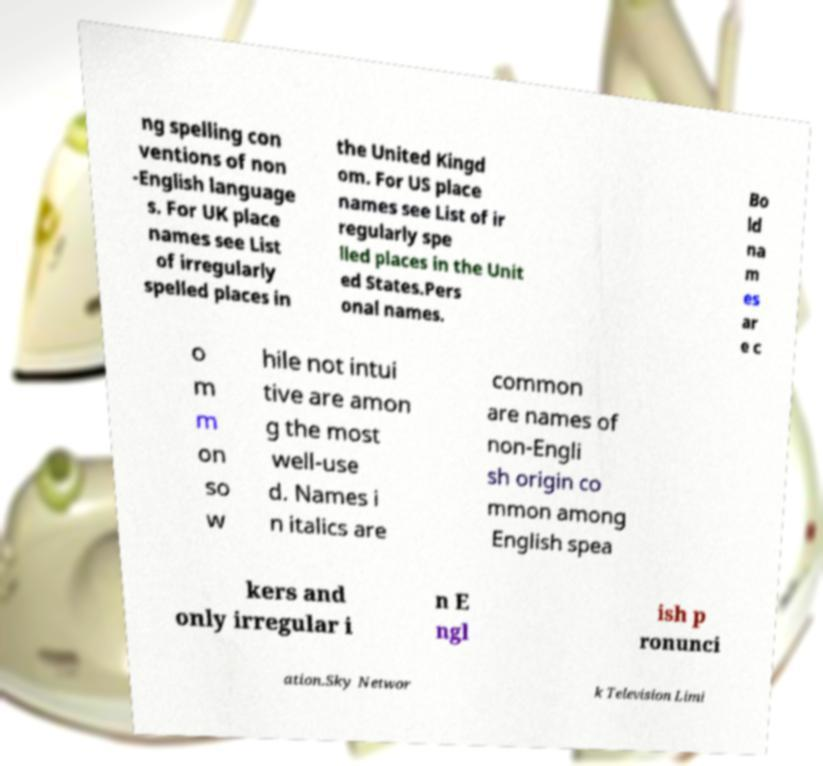Can you accurately transcribe the text from the provided image for me? ng spelling con ventions of non -English language s. For UK place names see List of irregularly spelled places in the United Kingd om. For US place names see List of ir regularly spe lled places in the Unit ed States.Pers onal names. Bo ld na m es ar e c o m m on so w hile not intui tive are amon g the most well-use d. Names i n italics are common are names of non-Engli sh origin co mmon among English spea kers and only irregular i n E ngl ish p ronunci ation.Sky Networ k Television Limi 